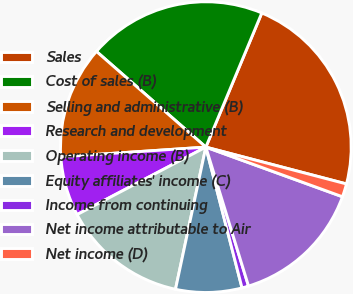Convert chart to OTSL. <chart><loc_0><loc_0><loc_500><loc_500><pie_chart><fcel>Sales<fcel>Cost of sales (B)<fcel>Selling and administrative (B)<fcel>Research and development<fcel>Operating income (B)<fcel>Equity affiliates' income (C)<fcel>Income from continuing<fcel>Net income attributable to Air<fcel>Net income (D)<nl><fcel>22.79%<fcel>19.85%<fcel>12.5%<fcel>6.62%<fcel>13.97%<fcel>7.35%<fcel>0.74%<fcel>14.71%<fcel>1.47%<nl></chart> 